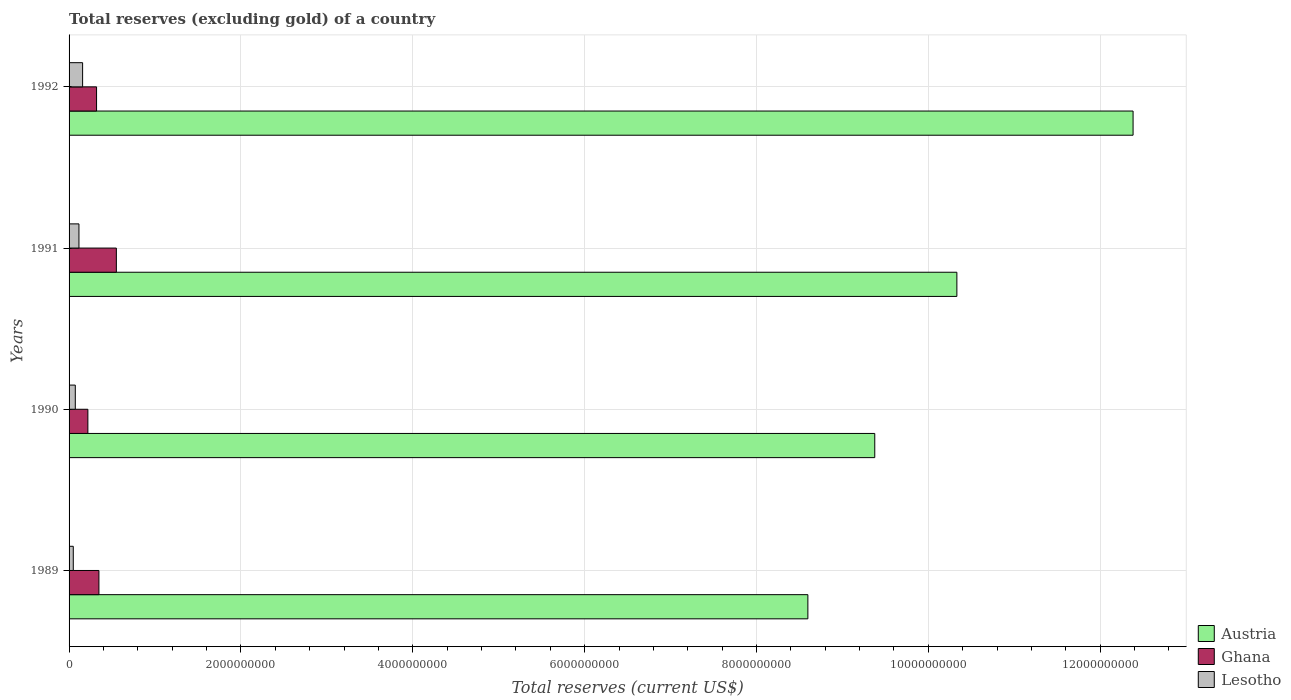How many groups of bars are there?
Provide a short and direct response. 4. In how many cases, is the number of bars for a given year not equal to the number of legend labels?
Provide a short and direct response. 0. What is the total reserves (excluding gold) in Austria in 1991?
Provide a succinct answer. 1.03e+1. Across all years, what is the maximum total reserves (excluding gold) in Ghana?
Provide a succinct answer. 5.50e+08. Across all years, what is the minimum total reserves (excluding gold) in Ghana?
Your response must be concise. 2.19e+08. In which year was the total reserves (excluding gold) in Lesotho maximum?
Provide a succinct answer. 1992. What is the total total reserves (excluding gold) in Ghana in the graph?
Your answer should be compact. 1.44e+09. What is the difference between the total reserves (excluding gold) in Ghana in 1990 and that in 1991?
Offer a terse response. -3.31e+08. What is the difference between the total reserves (excluding gold) in Lesotho in 1990 and the total reserves (excluding gold) in Austria in 1989?
Give a very brief answer. -8.53e+09. What is the average total reserves (excluding gold) in Ghana per year?
Offer a terse response. 3.59e+08. In the year 1989, what is the difference between the total reserves (excluding gold) in Ghana and total reserves (excluding gold) in Austria?
Your answer should be very brief. -8.25e+09. What is the ratio of the total reserves (excluding gold) in Lesotho in 1989 to that in 1991?
Keep it short and to the point. 0.43. Is the difference between the total reserves (excluding gold) in Ghana in 1991 and 1992 greater than the difference between the total reserves (excluding gold) in Austria in 1991 and 1992?
Ensure brevity in your answer.  Yes. What is the difference between the highest and the second highest total reserves (excluding gold) in Austria?
Give a very brief answer. 2.05e+09. What is the difference between the highest and the lowest total reserves (excluding gold) in Lesotho?
Provide a short and direct response. 1.08e+08. In how many years, is the total reserves (excluding gold) in Lesotho greater than the average total reserves (excluding gold) in Lesotho taken over all years?
Make the answer very short. 2. Is the sum of the total reserves (excluding gold) in Lesotho in 1989 and 1992 greater than the maximum total reserves (excluding gold) in Austria across all years?
Provide a succinct answer. No. What does the 3rd bar from the bottom in 1989 represents?
Keep it short and to the point. Lesotho. Is it the case that in every year, the sum of the total reserves (excluding gold) in Lesotho and total reserves (excluding gold) in Ghana is greater than the total reserves (excluding gold) in Austria?
Keep it short and to the point. No. How many bars are there?
Make the answer very short. 12. Are all the bars in the graph horizontal?
Provide a succinct answer. Yes. How many years are there in the graph?
Offer a terse response. 4. Does the graph contain grids?
Offer a very short reply. Yes. Where does the legend appear in the graph?
Offer a very short reply. Bottom right. How many legend labels are there?
Your answer should be very brief. 3. What is the title of the graph?
Provide a succinct answer. Total reserves (excluding gold) of a country. What is the label or title of the X-axis?
Provide a succinct answer. Total reserves (current US$). What is the Total reserves (current US$) in Austria in 1989?
Your response must be concise. 8.60e+09. What is the Total reserves (current US$) of Ghana in 1989?
Your answer should be very brief. 3.47e+08. What is the Total reserves (current US$) of Lesotho in 1989?
Provide a short and direct response. 4.90e+07. What is the Total reserves (current US$) in Austria in 1990?
Provide a succinct answer. 9.38e+09. What is the Total reserves (current US$) of Ghana in 1990?
Your response must be concise. 2.19e+08. What is the Total reserves (current US$) in Lesotho in 1990?
Make the answer very short. 7.24e+07. What is the Total reserves (current US$) in Austria in 1991?
Ensure brevity in your answer.  1.03e+1. What is the Total reserves (current US$) of Ghana in 1991?
Make the answer very short. 5.50e+08. What is the Total reserves (current US$) of Lesotho in 1991?
Offer a very short reply. 1.15e+08. What is the Total reserves (current US$) in Austria in 1992?
Give a very brief answer. 1.24e+1. What is the Total reserves (current US$) in Ghana in 1992?
Your answer should be very brief. 3.20e+08. What is the Total reserves (current US$) in Lesotho in 1992?
Provide a short and direct response. 1.57e+08. Across all years, what is the maximum Total reserves (current US$) of Austria?
Provide a short and direct response. 1.24e+1. Across all years, what is the maximum Total reserves (current US$) in Ghana?
Offer a terse response. 5.50e+08. Across all years, what is the maximum Total reserves (current US$) of Lesotho?
Provide a short and direct response. 1.57e+08. Across all years, what is the minimum Total reserves (current US$) of Austria?
Ensure brevity in your answer.  8.60e+09. Across all years, what is the minimum Total reserves (current US$) in Ghana?
Offer a terse response. 2.19e+08. Across all years, what is the minimum Total reserves (current US$) of Lesotho?
Your response must be concise. 4.90e+07. What is the total Total reserves (current US$) of Austria in the graph?
Make the answer very short. 4.07e+1. What is the total Total reserves (current US$) of Ghana in the graph?
Your response must be concise. 1.44e+09. What is the total Total reserves (current US$) of Lesotho in the graph?
Give a very brief answer. 3.94e+08. What is the difference between the Total reserves (current US$) of Austria in 1989 and that in 1990?
Your answer should be compact. -7.78e+08. What is the difference between the Total reserves (current US$) of Ghana in 1989 and that in 1990?
Make the answer very short. 1.28e+08. What is the difference between the Total reserves (current US$) in Lesotho in 1989 and that in 1990?
Give a very brief answer. -2.34e+07. What is the difference between the Total reserves (current US$) in Austria in 1989 and that in 1991?
Make the answer very short. -1.73e+09. What is the difference between the Total reserves (current US$) of Ghana in 1989 and that in 1991?
Give a very brief answer. -2.03e+08. What is the difference between the Total reserves (current US$) of Lesotho in 1989 and that in 1991?
Keep it short and to the point. -6.60e+07. What is the difference between the Total reserves (current US$) of Austria in 1989 and that in 1992?
Give a very brief answer. -3.78e+09. What is the difference between the Total reserves (current US$) of Ghana in 1989 and that in 1992?
Give a very brief answer. 2.74e+07. What is the difference between the Total reserves (current US$) in Lesotho in 1989 and that in 1992?
Offer a very short reply. -1.08e+08. What is the difference between the Total reserves (current US$) in Austria in 1990 and that in 1991?
Offer a terse response. -9.56e+08. What is the difference between the Total reserves (current US$) in Ghana in 1990 and that in 1991?
Provide a succinct answer. -3.31e+08. What is the difference between the Total reserves (current US$) in Lesotho in 1990 and that in 1991?
Keep it short and to the point. -4.27e+07. What is the difference between the Total reserves (current US$) in Austria in 1990 and that in 1992?
Provide a succinct answer. -3.01e+09. What is the difference between the Total reserves (current US$) of Ghana in 1990 and that in 1992?
Provide a succinct answer. -1.01e+08. What is the difference between the Total reserves (current US$) of Lesotho in 1990 and that in 1992?
Your response must be concise. -8.51e+07. What is the difference between the Total reserves (current US$) of Austria in 1991 and that in 1992?
Give a very brief answer. -2.05e+09. What is the difference between the Total reserves (current US$) in Ghana in 1991 and that in 1992?
Your response must be concise. 2.30e+08. What is the difference between the Total reserves (current US$) of Lesotho in 1991 and that in 1992?
Provide a succinct answer. -4.24e+07. What is the difference between the Total reserves (current US$) in Austria in 1989 and the Total reserves (current US$) in Ghana in 1990?
Give a very brief answer. 8.38e+09. What is the difference between the Total reserves (current US$) in Austria in 1989 and the Total reserves (current US$) in Lesotho in 1990?
Offer a terse response. 8.53e+09. What is the difference between the Total reserves (current US$) in Ghana in 1989 and the Total reserves (current US$) in Lesotho in 1990?
Offer a terse response. 2.75e+08. What is the difference between the Total reserves (current US$) in Austria in 1989 and the Total reserves (current US$) in Ghana in 1991?
Ensure brevity in your answer.  8.05e+09. What is the difference between the Total reserves (current US$) of Austria in 1989 and the Total reserves (current US$) of Lesotho in 1991?
Give a very brief answer. 8.48e+09. What is the difference between the Total reserves (current US$) in Ghana in 1989 and the Total reserves (current US$) in Lesotho in 1991?
Offer a very short reply. 2.32e+08. What is the difference between the Total reserves (current US$) of Austria in 1989 and the Total reserves (current US$) of Ghana in 1992?
Provide a short and direct response. 8.28e+09. What is the difference between the Total reserves (current US$) in Austria in 1989 and the Total reserves (current US$) in Lesotho in 1992?
Give a very brief answer. 8.44e+09. What is the difference between the Total reserves (current US$) of Ghana in 1989 and the Total reserves (current US$) of Lesotho in 1992?
Provide a short and direct response. 1.90e+08. What is the difference between the Total reserves (current US$) of Austria in 1990 and the Total reserves (current US$) of Ghana in 1991?
Offer a terse response. 8.83e+09. What is the difference between the Total reserves (current US$) in Austria in 1990 and the Total reserves (current US$) in Lesotho in 1991?
Offer a very short reply. 9.26e+09. What is the difference between the Total reserves (current US$) of Ghana in 1990 and the Total reserves (current US$) of Lesotho in 1991?
Your answer should be very brief. 1.04e+08. What is the difference between the Total reserves (current US$) in Austria in 1990 and the Total reserves (current US$) in Ghana in 1992?
Provide a short and direct response. 9.06e+09. What is the difference between the Total reserves (current US$) of Austria in 1990 and the Total reserves (current US$) of Lesotho in 1992?
Offer a very short reply. 9.22e+09. What is the difference between the Total reserves (current US$) in Ghana in 1990 and the Total reserves (current US$) in Lesotho in 1992?
Your answer should be very brief. 6.14e+07. What is the difference between the Total reserves (current US$) of Austria in 1991 and the Total reserves (current US$) of Ghana in 1992?
Your answer should be compact. 1.00e+1. What is the difference between the Total reserves (current US$) in Austria in 1991 and the Total reserves (current US$) in Lesotho in 1992?
Offer a very short reply. 1.02e+1. What is the difference between the Total reserves (current US$) in Ghana in 1991 and the Total reserves (current US$) in Lesotho in 1992?
Make the answer very short. 3.93e+08. What is the average Total reserves (current US$) in Austria per year?
Keep it short and to the point. 1.02e+1. What is the average Total reserves (current US$) of Ghana per year?
Provide a succinct answer. 3.59e+08. What is the average Total reserves (current US$) in Lesotho per year?
Provide a succinct answer. 9.85e+07. In the year 1989, what is the difference between the Total reserves (current US$) of Austria and Total reserves (current US$) of Ghana?
Your response must be concise. 8.25e+09. In the year 1989, what is the difference between the Total reserves (current US$) in Austria and Total reserves (current US$) in Lesotho?
Provide a succinct answer. 8.55e+09. In the year 1989, what is the difference between the Total reserves (current US$) in Ghana and Total reserves (current US$) in Lesotho?
Provide a short and direct response. 2.98e+08. In the year 1990, what is the difference between the Total reserves (current US$) in Austria and Total reserves (current US$) in Ghana?
Keep it short and to the point. 9.16e+09. In the year 1990, what is the difference between the Total reserves (current US$) of Austria and Total reserves (current US$) of Lesotho?
Your response must be concise. 9.30e+09. In the year 1990, what is the difference between the Total reserves (current US$) in Ghana and Total reserves (current US$) in Lesotho?
Your answer should be compact. 1.46e+08. In the year 1991, what is the difference between the Total reserves (current US$) in Austria and Total reserves (current US$) in Ghana?
Keep it short and to the point. 9.78e+09. In the year 1991, what is the difference between the Total reserves (current US$) of Austria and Total reserves (current US$) of Lesotho?
Ensure brevity in your answer.  1.02e+1. In the year 1991, what is the difference between the Total reserves (current US$) in Ghana and Total reserves (current US$) in Lesotho?
Keep it short and to the point. 4.35e+08. In the year 1992, what is the difference between the Total reserves (current US$) of Austria and Total reserves (current US$) of Ghana?
Your response must be concise. 1.21e+1. In the year 1992, what is the difference between the Total reserves (current US$) in Austria and Total reserves (current US$) in Lesotho?
Your answer should be very brief. 1.22e+1. In the year 1992, what is the difference between the Total reserves (current US$) in Ghana and Total reserves (current US$) in Lesotho?
Ensure brevity in your answer.  1.62e+08. What is the ratio of the Total reserves (current US$) of Austria in 1989 to that in 1990?
Your response must be concise. 0.92. What is the ratio of the Total reserves (current US$) in Ghana in 1989 to that in 1990?
Provide a short and direct response. 1.59. What is the ratio of the Total reserves (current US$) in Lesotho in 1989 to that in 1990?
Your answer should be very brief. 0.68. What is the ratio of the Total reserves (current US$) in Austria in 1989 to that in 1991?
Provide a short and direct response. 0.83. What is the ratio of the Total reserves (current US$) in Ghana in 1989 to that in 1991?
Provide a short and direct response. 0.63. What is the ratio of the Total reserves (current US$) in Lesotho in 1989 to that in 1991?
Your answer should be compact. 0.43. What is the ratio of the Total reserves (current US$) of Austria in 1989 to that in 1992?
Make the answer very short. 0.69. What is the ratio of the Total reserves (current US$) of Ghana in 1989 to that in 1992?
Offer a terse response. 1.09. What is the ratio of the Total reserves (current US$) of Lesotho in 1989 to that in 1992?
Your answer should be very brief. 0.31. What is the ratio of the Total reserves (current US$) of Austria in 1990 to that in 1991?
Make the answer very short. 0.91. What is the ratio of the Total reserves (current US$) of Ghana in 1990 to that in 1991?
Your answer should be compact. 0.4. What is the ratio of the Total reserves (current US$) in Lesotho in 1990 to that in 1991?
Give a very brief answer. 0.63. What is the ratio of the Total reserves (current US$) in Austria in 1990 to that in 1992?
Your answer should be compact. 0.76. What is the ratio of the Total reserves (current US$) in Ghana in 1990 to that in 1992?
Ensure brevity in your answer.  0.68. What is the ratio of the Total reserves (current US$) of Lesotho in 1990 to that in 1992?
Your answer should be compact. 0.46. What is the ratio of the Total reserves (current US$) in Austria in 1991 to that in 1992?
Keep it short and to the point. 0.83. What is the ratio of the Total reserves (current US$) in Ghana in 1991 to that in 1992?
Make the answer very short. 1.72. What is the ratio of the Total reserves (current US$) in Lesotho in 1991 to that in 1992?
Your answer should be compact. 0.73. What is the difference between the highest and the second highest Total reserves (current US$) in Austria?
Provide a short and direct response. 2.05e+09. What is the difference between the highest and the second highest Total reserves (current US$) in Ghana?
Make the answer very short. 2.03e+08. What is the difference between the highest and the second highest Total reserves (current US$) in Lesotho?
Your answer should be compact. 4.24e+07. What is the difference between the highest and the lowest Total reserves (current US$) in Austria?
Keep it short and to the point. 3.78e+09. What is the difference between the highest and the lowest Total reserves (current US$) in Ghana?
Keep it short and to the point. 3.31e+08. What is the difference between the highest and the lowest Total reserves (current US$) of Lesotho?
Provide a short and direct response. 1.08e+08. 